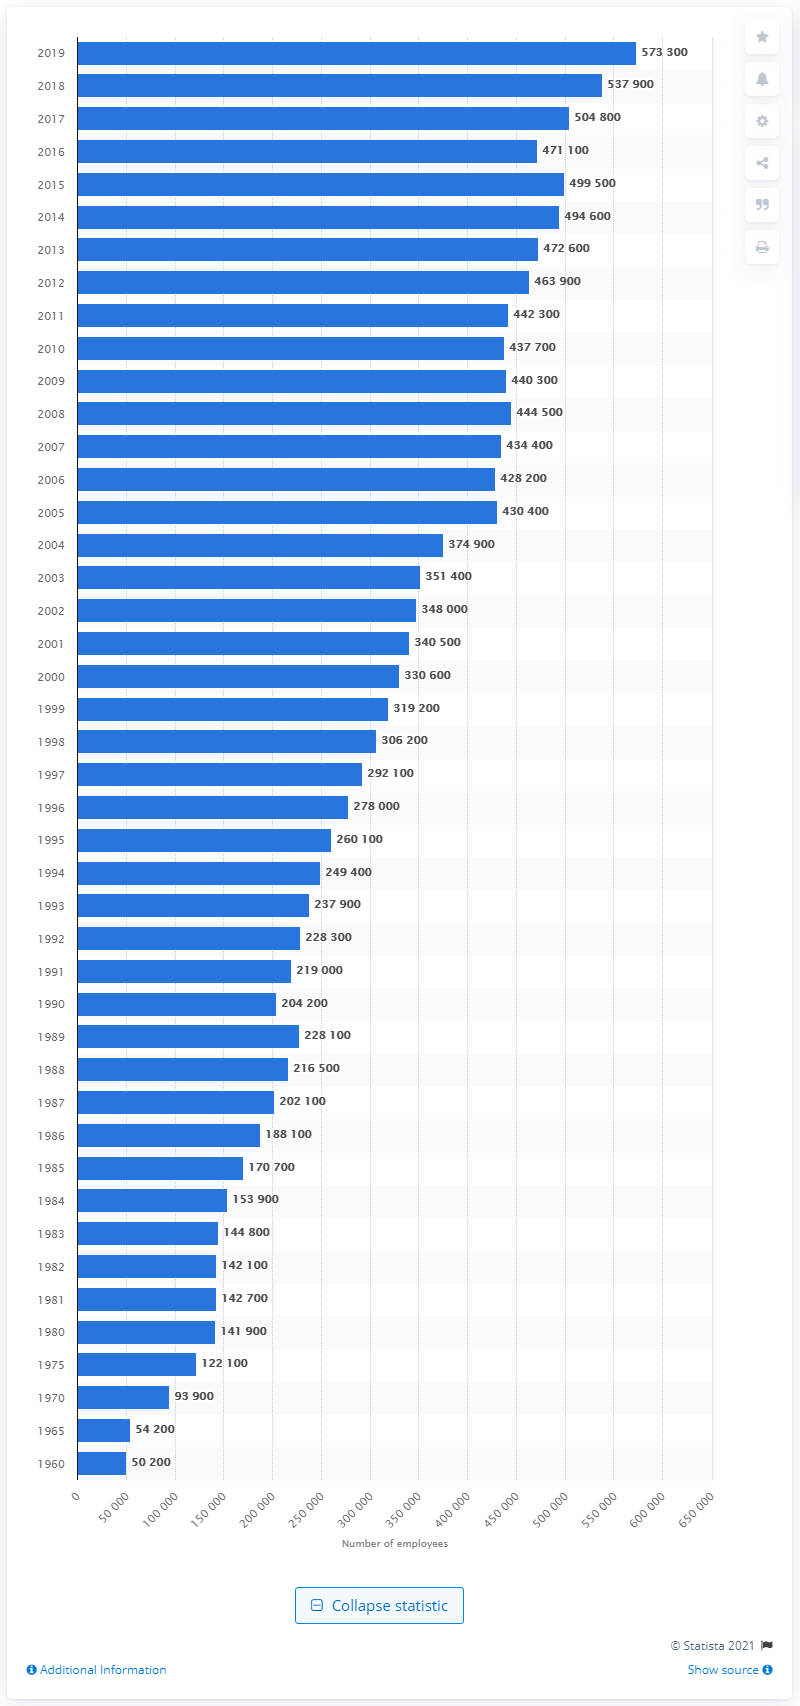Point out several critical features in this image. There were approximately 573,300 health insurance employees in the United States in 2019. 